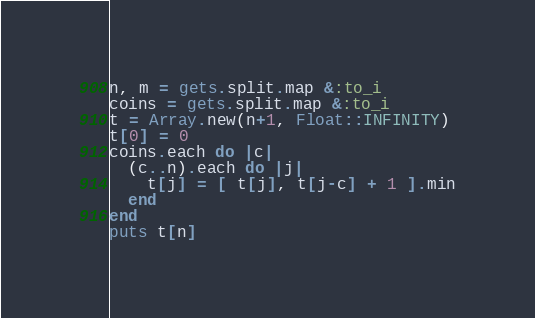<code> <loc_0><loc_0><loc_500><loc_500><_Ruby_>n, m = gets.split.map &:to_i
coins = gets.split.map &:to_i
t = Array.new(n+1, Float::INFINITY)
t[0] = 0
coins.each do |c|
  (c..n).each do |j|
    t[j] = [ t[j], t[j-c] + 1 ].min
  end
end
puts t[n]</code> 